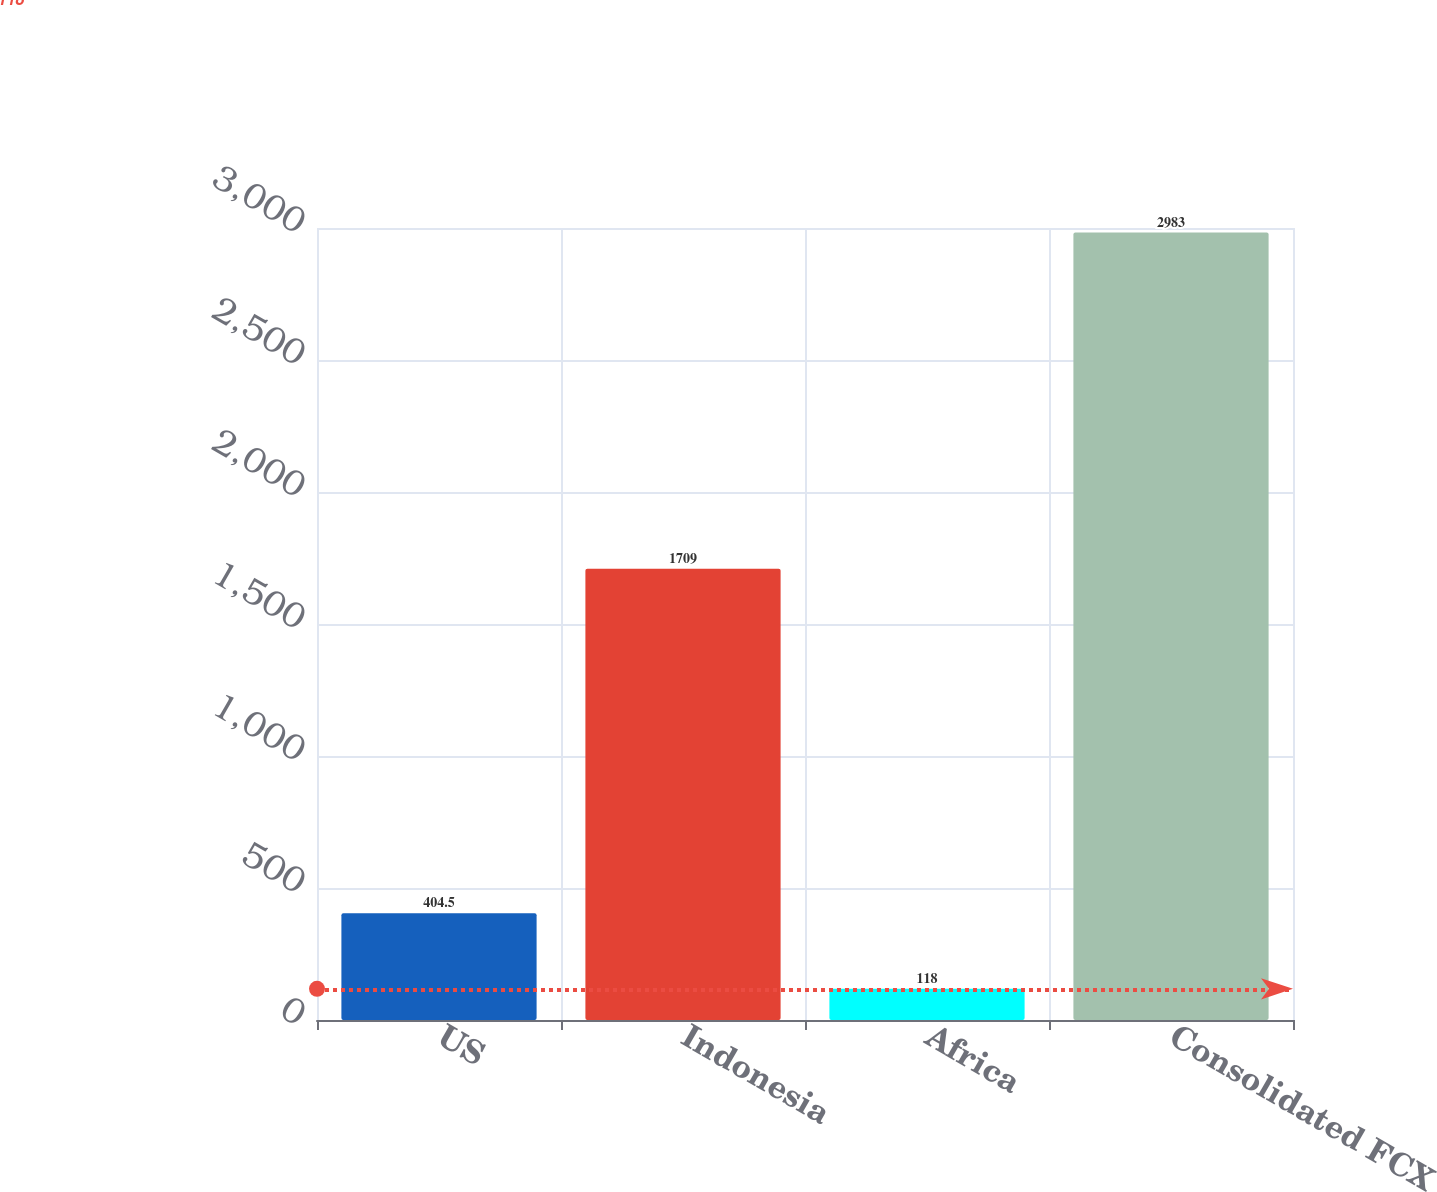<chart> <loc_0><loc_0><loc_500><loc_500><bar_chart><fcel>US<fcel>Indonesia<fcel>Africa<fcel>Consolidated FCX<nl><fcel>404.5<fcel>1709<fcel>118<fcel>2983<nl></chart> 